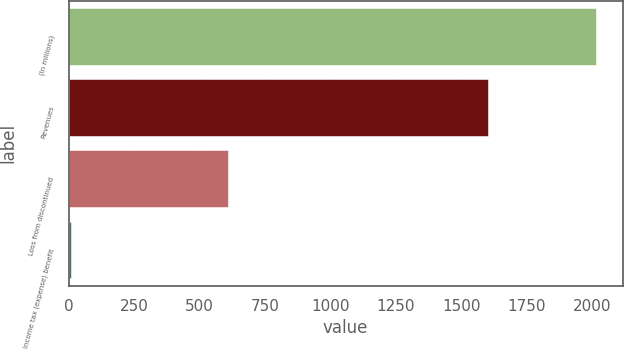<chart> <loc_0><loc_0><loc_500><loc_500><bar_chart><fcel>(In millions)<fcel>Revenues<fcel>Loss from discontinued<fcel>Income tax (expense) benefit<nl><fcel>2016<fcel>1603<fcel>610.4<fcel>8<nl></chart> 